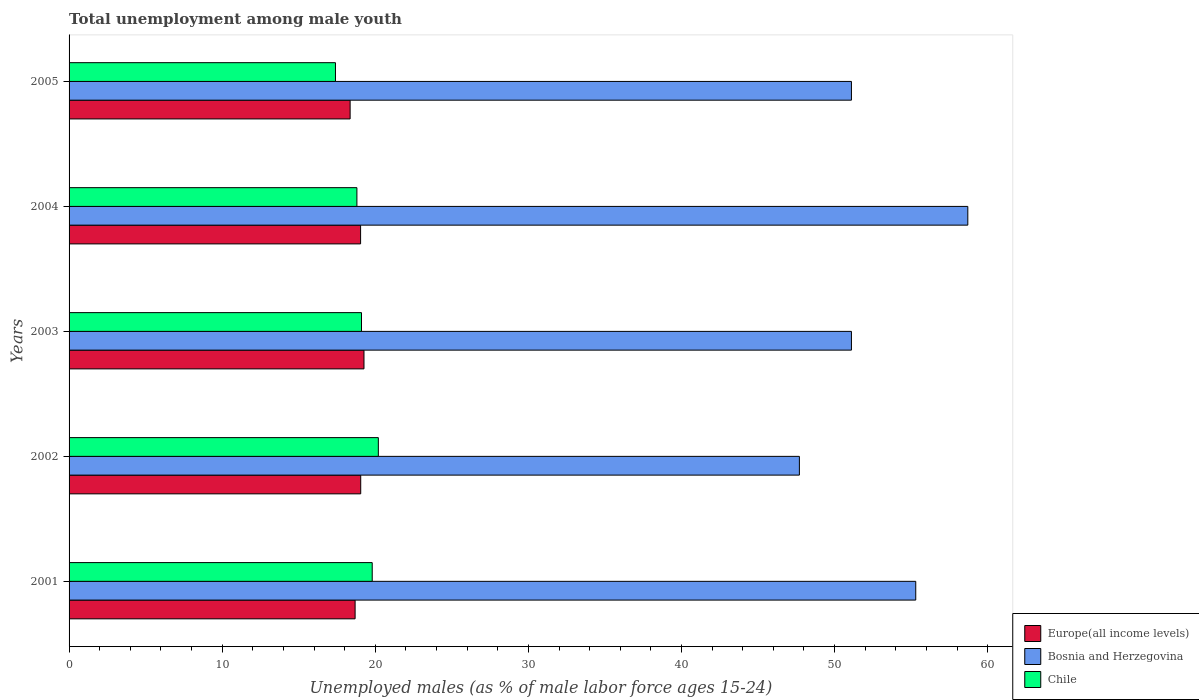How many different coloured bars are there?
Your response must be concise. 3. Are the number of bars per tick equal to the number of legend labels?
Offer a terse response. Yes. How many bars are there on the 2nd tick from the top?
Keep it short and to the point. 3. In how many cases, is the number of bars for a given year not equal to the number of legend labels?
Keep it short and to the point. 0. What is the percentage of unemployed males in in Chile in 2001?
Keep it short and to the point. 19.8. Across all years, what is the maximum percentage of unemployed males in in Chile?
Ensure brevity in your answer.  20.2. Across all years, what is the minimum percentage of unemployed males in in Bosnia and Herzegovina?
Offer a very short reply. 47.7. In which year was the percentage of unemployed males in in Europe(all income levels) maximum?
Offer a very short reply. 2003. In which year was the percentage of unemployed males in in Europe(all income levels) minimum?
Your answer should be very brief. 2005. What is the total percentage of unemployed males in in Chile in the graph?
Ensure brevity in your answer.  95.3. What is the difference between the percentage of unemployed males in in Europe(all income levels) in 2002 and that in 2003?
Provide a short and direct response. -0.21. What is the difference between the percentage of unemployed males in in Bosnia and Herzegovina in 2001 and the percentage of unemployed males in in Europe(all income levels) in 2003?
Offer a terse response. 36.04. What is the average percentage of unemployed males in in Europe(all income levels) per year?
Your answer should be very brief. 18.88. In the year 2001, what is the difference between the percentage of unemployed males in in Bosnia and Herzegovina and percentage of unemployed males in in Europe(all income levels)?
Ensure brevity in your answer.  36.62. In how many years, is the percentage of unemployed males in in Europe(all income levels) greater than 16 %?
Keep it short and to the point. 5. What is the ratio of the percentage of unemployed males in in Europe(all income levels) in 2003 to that in 2004?
Offer a terse response. 1.01. Is the percentage of unemployed males in in Europe(all income levels) in 2002 less than that in 2005?
Offer a very short reply. No. What is the difference between the highest and the second highest percentage of unemployed males in in Europe(all income levels)?
Your response must be concise. 0.21. What is the difference between the highest and the lowest percentage of unemployed males in in Bosnia and Herzegovina?
Offer a very short reply. 11. What does the 1st bar from the top in 2001 represents?
Your answer should be very brief. Chile. What does the 2nd bar from the bottom in 2003 represents?
Offer a terse response. Bosnia and Herzegovina. Are all the bars in the graph horizontal?
Offer a very short reply. Yes. How many years are there in the graph?
Make the answer very short. 5. What is the difference between two consecutive major ticks on the X-axis?
Provide a short and direct response. 10. Are the values on the major ticks of X-axis written in scientific E-notation?
Your answer should be compact. No. Does the graph contain grids?
Your answer should be compact. No. How many legend labels are there?
Your answer should be very brief. 3. How are the legend labels stacked?
Provide a succinct answer. Vertical. What is the title of the graph?
Provide a short and direct response. Total unemployment among male youth. What is the label or title of the X-axis?
Provide a short and direct response. Unemployed males (as % of male labor force ages 15-24). What is the Unemployed males (as % of male labor force ages 15-24) in Europe(all income levels) in 2001?
Your answer should be compact. 18.68. What is the Unemployed males (as % of male labor force ages 15-24) in Bosnia and Herzegovina in 2001?
Offer a very short reply. 55.3. What is the Unemployed males (as % of male labor force ages 15-24) of Chile in 2001?
Provide a short and direct response. 19.8. What is the Unemployed males (as % of male labor force ages 15-24) of Europe(all income levels) in 2002?
Keep it short and to the point. 19.05. What is the Unemployed males (as % of male labor force ages 15-24) in Bosnia and Herzegovina in 2002?
Provide a succinct answer. 47.7. What is the Unemployed males (as % of male labor force ages 15-24) of Chile in 2002?
Offer a very short reply. 20.2. What is the Unemployed males (as % of male labor force ages 15-24) in Europe(all income levels) in 2003?
Your response must be concise. 19.26. What is the Unemployed males (as % of male labor force ages 15-24) in Bosnia and Herzegovina in 2003?
Provide a succinct answer. 51.1. What is the Unemployed males (as % of male labor force ages 15-24) in Chile in 2003?
Give a very brief answer. 19.1. What is the Unemployed males (as % of male labor force ages 15-24) in Europe(all income levels) in 2004?
Your answer should be compact. 19.04. What is the Unemployed males (as % of male labor force ages 15-24) in Bosnia and Herzegovina in 2004?
Give a very brief answer. 58.7. What is the Unemployed males (as % of male labor force ages 15-24) of Chile in 2004?
Your answer should be very brief. 18.8. What is the Unemployed males (as % of male labor force ages 15-24) in Europe(all income levels) in 2005?
Provide a succinct answer. 18.36. What is the Unemployed males (as % of male labor force ages 15-24) in Bosnia and Herzegovina in 2005?
Make the answer very short. 51.1. What is the Unemployed males (as % of male labor force ages 15-24) of Chile in 2005?
Make the answer very short. 17.4. Across all years, what is the maximum Unemployed males (as % of male labor force ages 15-24) of Europe(all income levels)?
Your response must be concise. 19.26. Across all years, what is the maximum Unemployed males (as % of male labor force ages 15-24) of Bosnia and Herzegovina?
Provide a short and direct response. 58.7. Across all years, what is the maximum Unemployed males (as % of male labor force ages 15-24) in Chile?
Offer a very short reply. 20.2. Across all years, what is the minimum Unemployed males (as % of male labor force ages 15-24) of Europe(all income levels)?
Provide a short and direct response. 18.36. Across all years, what is the minimum Unemployed males (as % of male labor force ages 15-24) in Bosnia and Herzegovina?
Give a very brief answer. 47.7. Across all years, what is the minimum Unemployed males (as % of male labor force ages 15-24) in Chile?
Keep it short and to the point. 17.4. What is the total Unemployed males (as % of male labor force ages 15-24) in Europe(all income levels) in the graph?
Offer a very short reply. 94.39. What is the total Unemployed males (as % of male labor force ages 15-24) in Bosnia and Herzegovina in the graph?
Keep it short and to the point. 263.9. What is the total Unemployed males (as % of male labor force ages 15-24) in Chile in the graph?
Make the answer very short. 95.3. What is the difference between the Unemployed males (as % of male labor force ages 15-24) in Europe(all income levels) in 2001 and that in 2002?
Offer a very short reply. -0.37. What is the difference between the Unemployed males (as % of male labor force ages 15-24) in Bosnia and Herzegovina in 2001 and that in 2002?
Provide a short and direct response. 7.6. What is the difference between the Unemployed males (as % of male labor force ages 15-24) of Chile in 2001 and that in 2002?
Offer a very short reply. -0.4. What is the difference between the Unemployed males (as % of male labor force ages 15-24) in Europe(all income levels) in 2001 and that in 2003?
Your response must be concise. -0.58. What is the difference between the Unemployed males (as % of male labor force ages 15-24) of Europe(all income levels) in 2001 and that in 2004?
Offer a terse response. -0.36. What is the difference between the Unemployed males (as % of male labor force ages 15-24) of Chile in 2001 and that in 2004?
Provide a succinct answer. 1. What is the difference between the Unemployed males (as % of male labor force ages 15-24) of Europe(all income levels) in 2001 and that in 2005?
Provide a succinct answer. 0.33. What is the difference between the Unemployed males (as % of male labor force ages 15-24) in Chile in 2001 and that in 2005?
Offer a terse response. 2.4. What is the difference between the Unemployed males (as % of male labor force ages 15-24) of Europe(all income levels) in 2002 and that in 2003?
Provide a short and direct response. -0.21. What is the difference between the Unemployed males (as % of male labor force ages 15-24) in Chile in 2002 and that in 2003?
Your answer should be very brief. 1.1. What is the difference between the Unemployed males (as % of male labor force ages 15-24) in Europe(all income levels) in 2002 and that in 2004?
Ensure brevity in your answer.  0.01. What is the difference between the Unemployed males (as % of male labor force ages 15-24) of Chile in 2002 and that in 2004?
Your response must be concise. 1.4. What is the difference between the Unemployed males (as % of male labor force ages 15-24) in Europe(all income levels) in 2002 and that in 2005?
Offer a terse response. 0.69. What is the difference between the Unemployed males (as % of male labor force ages 15-24) in Chile in 2002 and that in 2005?
Give a very brief answer. 2.8. What is the difference between the Unemployed males (as % of male labor force ages 15-24) in Europe(all income levels) in 2003 and that in 2004?
Make the answer very short. 0.22. What is the difference between the Unemployed males (as % of male labor force ages 15-24) in Europe(all income levels) in 2003 and that in 2005?
Give a very brief answer. 0.91. What is the difference between the Unemployed males (as % of male labor force ages 15-24) in Bosnia and Herzegovina in 2003 and that in 2005?
Keep it short and to the point. 0. What is the difference between the Unemployed males (as % of male labor force ages 15-24) of Chile in 2003 and that in 2005?
Provide a short and direct response. 1.7. What is the difference between the Unemployed males (as % of male labor force ages 15-24) of Europe(all income levels) in 2004 and that in 2005?
Your answer should be compact. 0.68. What is the difference between the Unemployed males (as % of male labor force ages 15-24) in Europe(all income levels) in 2001 and the Unemployed males (as % of male labor force ages 15-24) in Bosnia and Herzegovina in 2002?
Offer a very short reply. -29.02. What is the difference between the Unemployed males (as % of male labor force ages 15-24) of Europe(all income levels) in 2001 and the Unemployed males (as % of male labor force ages 15-24) of Chile in 2002?
Give a very brief answer. -1.52. What is the difference between the Unemployed males (as % of male labor force ages 15-24) in Bosnia and Herzegovina in 2001 and the Unemployed males (as % of male labor force ages 15-24) in Chile in 2002?
Provide a succinct answer. 35.1. What is the difference between the Unemployed males (as % of male labor force ages 15-24) in Europe(all income levels) in 2001 and the Unemployed males (as % of male labor force ages 15-24) in Bosnia and Herzegovina in 2003?
Offer a terse response. -32.42. What is the difference between the Unemployed males (as % of male labor force ages 15-24) in Europe(all income levels) in 2001 and the Unemployed males (as % of male labor force ages 15-24) in Chile in 2003?
Provide a short and direct response. -0.42. What is the difference between the Unemployed males (as % of male labor force ages 15-24) of Bosnia and Herzegovina in 2001 and the Unemployed males (as % of male labor force ages 15-24) of Chile in 2003?
Offer a terse response. 36.2. What is the difference between the Unemployed males (as % of male labor force ages 15-24) of Europe(all income levels) in 2001 and the Unemployed males (as % of male labor force ages 15-24) of Bosnia and Herzegovina in 2004?
Keep it short and to the point. -40.02. What is the difference between the Unemployed males (as % of male labor force ages 15-24) in Europe(all income levels) in 2001 and the Unemployed males (as % of male labor force ages 15-24) in Chile in 2004?
Keep it short and to the point. -0.12. What is the difference between the Unemployed males (as % of male labor force ages 15-24) of Bosnia and Herzegovina in 2001 and the Unemployed males (as % of male labor force ages 15-24) of Chile in 2004?
Your response must be concise. 36.5. What is the difference between the Unemployed males (as % of male labor force ages 15-24) of Europe(all income levels) in 2001 and the Unemployed males (as % of male labor force ages 15-24) of Bosnia and Herzegovina in 2005?
Make the answer very short. -32.42. What is the difference between the Unemployed males (as % of male labor force ages 15-24) of Europe(all income levels) in 2001 and the Unemployed males (as % of male labor force ages 15-24) of Chile in 2005?
Keep it short and to the point. 1.28. What is the difference between the Unemployed males (as % of male labor force ages 15-24) in Bosnia and Herzegovina in 2001 and the Unemployed males (as % of male labor force ages 15-24) in Chile in 2005?
Give a very brief answer. 37.9. What is the difference between the Unemployed males (as % of male labor force ages 15-24) in Europe(all income levels) in 2002 and the Unemployed males (as % of male labor force ages 15-24) in Bosnia and Herzegovina in 2003?
Offer a terse response. -32.05. What is the difference between the Unemployed males (as % of male labor force ages 15-24) in Europe(all income levels) in 2002 and the Unemployed males (as % of male labor force ages 15-24) in Chile in 2003?
Make the answer very short. -0.05. What is the difference between the Unemployed males (as % of male labor force ages 15-24) of Bosnia and Herzegovina in 2002 and the Unemployed males (as % of male labor force ages 15-24) of Chile in 2003?
Your answer should be compact. 28.6. What is the difference between the Unemployed males (as % of male labor force ages 15-24) of Europe(all income levels) in 2002 and the Unemployed males (as % of male labor force ages 15-24) of Bosnia and Herzegovina in 2004?
Make the answer very short. -39.65. What is the difference between the Unemployed males (as % of male labor force ages 15-24) in Europe(all income levels) in 2002 and the Unemployed males (as % of male labor force ages 15-24) in Chile in 2004?
Offer a very short reply. 0.25. What is the difference between the Unemployed males (as % of male labor force ages 15-24) of Bosnia and Herzegovina in 2002 and the Unemployed males (as % of male labor force ages 15-24) of Chile in 2004?
Your answer should be compact. 28.9. What is the difference between the Unemployed males (as % of male labor force ages 15-24) of Europe(all income levels) in 2002 and the Unemployed males (as % of male labor force ages 15-24) of Bosnia and Herzegovina in 2005?
Provide a short and direct response. -32.05. What is the difference between the Unemployed males (as % of male labor force ages 15-24) of Europe(all income levels) in 2002 and the Unemployed males (as % of male labor force ages 15-24) of Chile in 2005?
Your response must be concise. 1.65. What is the difference between the Unemployed males (as % of male labor force ages 15-24) of Bosnia and Herzegovina in 2002 and the Unemployed males (as % of male labor force ages 15-24) of Chile in 2005?
Provide a succinct answer. 30.3. What is the difference between the Unemployed males (as % of male labor force ages 15-24) of Europe(all income levels) in 2003 and the Unemployed males (as % of male labor force ages 15-24) of Bosnia and Herzegovina in 2004?
Provide a short and direct response. -39.44. What is the difference between the Unemployed males (as % of male labor force ages 15-24) in Europe(all income levels) in 2003 and the Unemployed males (as % of male labor force ages 15-24) in Chile in 2004?
Make the answer very short. 0.46. What is the difference between the Unemployed males (as % of male labor force ages 15-24) in Bosnia and Herzegovina in 2003 and the Unemployed males (as % of male labor force ages 15-24) in Chile in 2004?
Give a very brief answer. 32.3. What is the difference between the Unemployed males (as % of male labor force ages 15-24) in Europe(all income levels) in 2003 and the Unemployed males (as % of male labor force ages 15-24) in Bosnia and Herzegovina in 2005?
Your answer should be very brief. -31.84. What is the difference between the Unemployed males (as % of male labor force ages 15-24) in Europe(all income levels) in 2003 and the Unemployed males (as % of male labor force ages 15-24) in Chile in 2005?
Give a very brief answer. 1.86. What is the difference between the Unemployed males (as % of male labor force ages 15-24) in Bosnia and Herzegovina in 2003 and the Unemployed males (as % of male labor force ages 15-24) in Chile in 2005?
Ensure brevity in your answer.  33.7. What is the difference between the Unemployed males (as % of male labor force ages 15-24) in Europe(all income levels) in 2004 and the Unemployed males (as % of male labor force ages 15-24) in Bosnia and Herzegovina in 2005?
Ensure brevity in your answer.  -32.06. What is the difference between the Unemployed males (as % of male labor force ages 15-24) in Europe(all income levels) in 2004 and the Unemployed males (as % of male labor force ages 15-24) in Chile in 2005?
Provide a succinct answer. 1.64. What is the difference between the Unemployed males (as % of male labor force ages 15-24) in Bosnia and Herzegovina in 2004 and the Unemployed males (as % of male labor force ages 15-24) in Chile in 2005?
Keep it short and to the point. 41.3. What is the average Unemployed males (as % of male labor force ages 15-24) of Europe(all income levels) per year?
Your answer should be compact. 18.88. What is the average Unemployed males (as % of male labor force ages 15-24) in Bosnia and Herzegovina per year?
Provide a short and direct response. 52.78. What is the average Unemployed males (as % of male labor force ages 15-24) of Chile per year?
Offer a very short reply. 19.06. In the year 2001, what is the difference between the Unemployed males (as % of male labor force ages 15-24) of Europe(all income levels) and Unemployed males (as % of male labor force ages 15-24) of Bosnia and Herzegovina?
Keep it short and to the point. -36.62. In the year 2001, what is the difference between the Unemployed males (as % of male labor force ages 15-24) of Europe(all income levels) and Unemployed males (as % of male labor force ages 15-24) of Chile?
Keep it short and to the point. -1.12. In the year 2001, what is the difference between the Unemployed males (as % of male labor force ages 15-24) in Bosnia and Herzegovina and Unemployed males (as % of male labor force ages 15-24) in Chile?
Ensure brevity in your answer.  35.5. In the year 2002, what is the difference between the Unemployed males (as % of male labor force ages 15-24) in Europe(all income levels) and Unemployed males (as % of male labor force ages 15-24) in Bosnia and Herzegovina?
Provide a succinct answer. -28.65. In the year 2002, what is the difference between the Unemployed males (as % of male labor force ages 15-24) in Europe(all income levels) and Unemployed males (as % of male labor force ages 15-24) in Chile?
Your response must be concise. -1.15. In the year 2002, what is the difference between the Unemployed males (as % of male labor force ages 15-24) of Bosnia and Herzegovina and Unemployed males (as % of male labor force ages 15-24) of Chile?
Provide a short and direct response. 27.5. In the year 2003, what is the difference between the Unemployed males (as % of male labor force ages 15-24) of Europe(all income levels) and Unemployed males (as % of male labor force ages 15-24) of Bosnia and Herzegovina?
Provide a short and direct response. -31.84. In the year 2003, what is the difference between the Unemployed males (as % of male labor force ages 15-24) of Europe(all income levels) and Unemployed males (as % of male labor force ages 15-24) of Chile?
Your answer should be compact. 0.16. In the year 2004, what is the difference between the Unemployed males (as % of male labor force ages 15-24) in Europe(all income levels) and Unemployed males (as % of male labor force ages 15-24) in Bosnia and Herzegovina?
Offer a very short reply. -39.66. In the year 2004, what is the difference between the Unemployed males (as % of male labor force ages 15-24) in Europe(all income levels) and Unemployed males (as % of male labor force ages 15-24) in Chile?
Your answer should be very brief. 0.24. In the year 2004, what is the difference between the Unemployed males (as % of male labor force ages 15-24) of Bosnia and Herzegovina and Unemployed males (as % of male labor force ages 15-24) of Chile?
Provide a succinct answer. 39.9. In the year 2005, what is the difference between the Unemployed males (as % of male labor force ages 15-24) of Europe(all income levels) and Unemployed males (as % of male labor force ages 15-24) of Bosnia and Herzegovina?
Your answer should be compact. -32.74. In the year 2005, what is the difference between the Unemployed males (as % of male labor force ages 15-24) of Europe(all income levels) and Unemployed males (as % of male labor force ages 15-24) of Chile?
Provide a succinct answer. 0.96. In the year 2005, what is the difference between the Unemployed males (as % of male labor force ages 15-24) in Bosnia and Herzegovina and Unemployed males (as % of male labor force ages 15-24) in Chile?
Provide a succinct answer. 33.7. What is the ratio of the Unemployed males (as % of male labor force ages 15-24) in Europe(all income levels) in 2001 to that in 2002?
Keep it short and to the point. 0.98. What is the ratio of the Unemployed males (as % of male labor force ages 15-24) of Bosnia and Herzegovina in 2001 to that in 2002?
Provide a short and direct response. 1.16. What is the ratio of the Unemployed males (as % of male labor force ages 15-24) in Chile in 2001 to that in 2002?
Keep it short and to the point. 0.98. What is the ratio of the Unemployed males (as % of male labor force ages 15-24) of Europe(all income levels) in 2001 to that in 2003?
Your answer should be compact. 0.97. What is the ratio of the Unemployed males (as % of male labor force ages 15-24) of Bosnia and Herzegovina in 2001 to that in 2003?
Your answer should be compact. 1.08. What is the ratio of the Unemployed males (as % of male labor force ages 15-24) of Chile in 2001 to that in 2003?
Provide a succinct answer. 1.04. What is the ratio of the Unemployed males (as % of male labor force ages 15-24) of Europe(all income levels) in 2001 to that in 2004?
Offer a terse response. 0.98. What is the ratio of the Unemployed males (as % of male labor force ages 15-24) of Bosnia and Herzegovina in 2001 to that in 2004?
Your response must be concise. 0.94. What is the ratio of the Unemployed males (as % of male labor force ages 15-24) in Chile in 2001 to that in 2004?
Your answer should be compact. 1.05. What is the ratio of the Unemployed males (as % of male labor force ages 15-24) in Europe(all income levels) in 2001 to that in 2005?
Provide a succinct answer. 1.02. What is the ratio of the Unemployed males (as % of male labor force ages 15-24) of Bosnia and Herzegovina in 2001 to that in 2005?
Your answer should be very brief. 1.08. What is the ratio of the Unemployed males (as % of male labor force ages 15-24) in Chile in 2001 to that in 2005?
Provide a short and direct response. 1.14. What is the ratio of the Unemployed males (as % of male labor force ages 15-24) of Europe(all income levels) in 2002 to that in 2003?
Your answer should be compact. 0.99. What is the ratio of the Unemployed males (as % of male labor force ages 15-24) in Bosnia and Herzegovina in 2002 to that in 2003?
Make the answer very short. 0.93. What is the ratio of the Unemployed males (as % of male labor force ages 15-24) in Chile in 2002 to that in 2003?
Your response must be concise. 1.06. What is the ratio of the Unemployed males (as % of male labor force ages 15-24) of Europe(all income levels) in 2002 to that in 2004?
Offer a terse response. 1. What is the ratio of the Unemployed males (as % of male labor force ages 15-24) of Bosnia and Herzegovina in 2002 to that in 2004?
Offer a very short reply. 0.81. What is the ratio of the Unemployed males (as % of male labor force ages 15-24) of Chile in 2002 to that in 2004?
Your answer should be very brief. 1.07. What is the ratio of the Unemployed males (as % of male labor force ages 15-24) in Europe(all income levels) in 2002 to that in 2005?
Provide a short and direct response. 1.04. What is the ratio of the Unemployed males (as % of male labor force ages 15-24) of Bosnia and Herzegovina in 2002 to that in 2005?
Your answer should be very brief. 0.93. What is the ratio of the Unemployed males (as % of male labor force ages 15-24) of Chile in 2002 to that in 2005?
Offer a terse response. 1.16. What is the ratio of the Unemployed males (as % of male labor force ages 15-24) in Europe(all income levels) in 2003 to that in 2004?
Make the answer very short. 1.01. What is the ratio of the Unemployed males (as % of male labor force ages 15-24) of Bosnia and Herzegovina in 2003 to that in 2004?
Offer a terse response. 0.87. What is the ratio of the Unemployed males (as % of male labor force ages 15-24) in Europe(all income levels) in 2003 to that in 2005?
Provide a short and direct response. 1.05. What is the ratio of the Unemployed males (as % of male labor force ages 15-24) in Chile in 2003 to that in 2005?
Provide a succinct answer. 1.1. What is the ratio of the Unemployed males (as % of male labor force ages 15-24) of Europe(all income levels) in 2004 to that in 2005?
Offer a terse response. 1.04. What is the ratio of the Unemployed males (as % of male labor force ages 15-24) of Bosnia and Herzegovina in 2004 to that in 2005?
Your answer should be very brief. 1.15. What is the ratio of the Unemployed males (as % of male labor force ages 15-24) in Chile in 2004 to that in 2005?
Ensure brevity in your answer.  1.08. What is the difference between the highest and the second highest Unemployed males (as % of male labor force ages 15-24) in Europe(all income levels)?
Give a very brief answer. 0.21. What is the difference between the highest and the second highest Unemployed males (as % of male labor force ages 15-24) in Bosnia and Herzegovina?
Offer a very short reply. 3.4. What is the difference between the highest and the lowest Unemployed males (as % of male labor force ages 15-24) of Europe(all income levels)?
Your answer should be very brief. 0.91. 